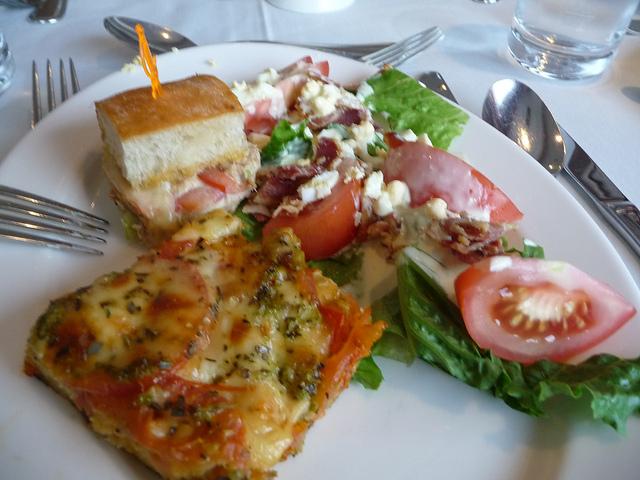Is everything on the plate edible?
Answer briefly. No. What color is the sword holding the sandwich together?
Short answer required. Orange. How would a food critic rate this meal?
Concise answer only. Good. 